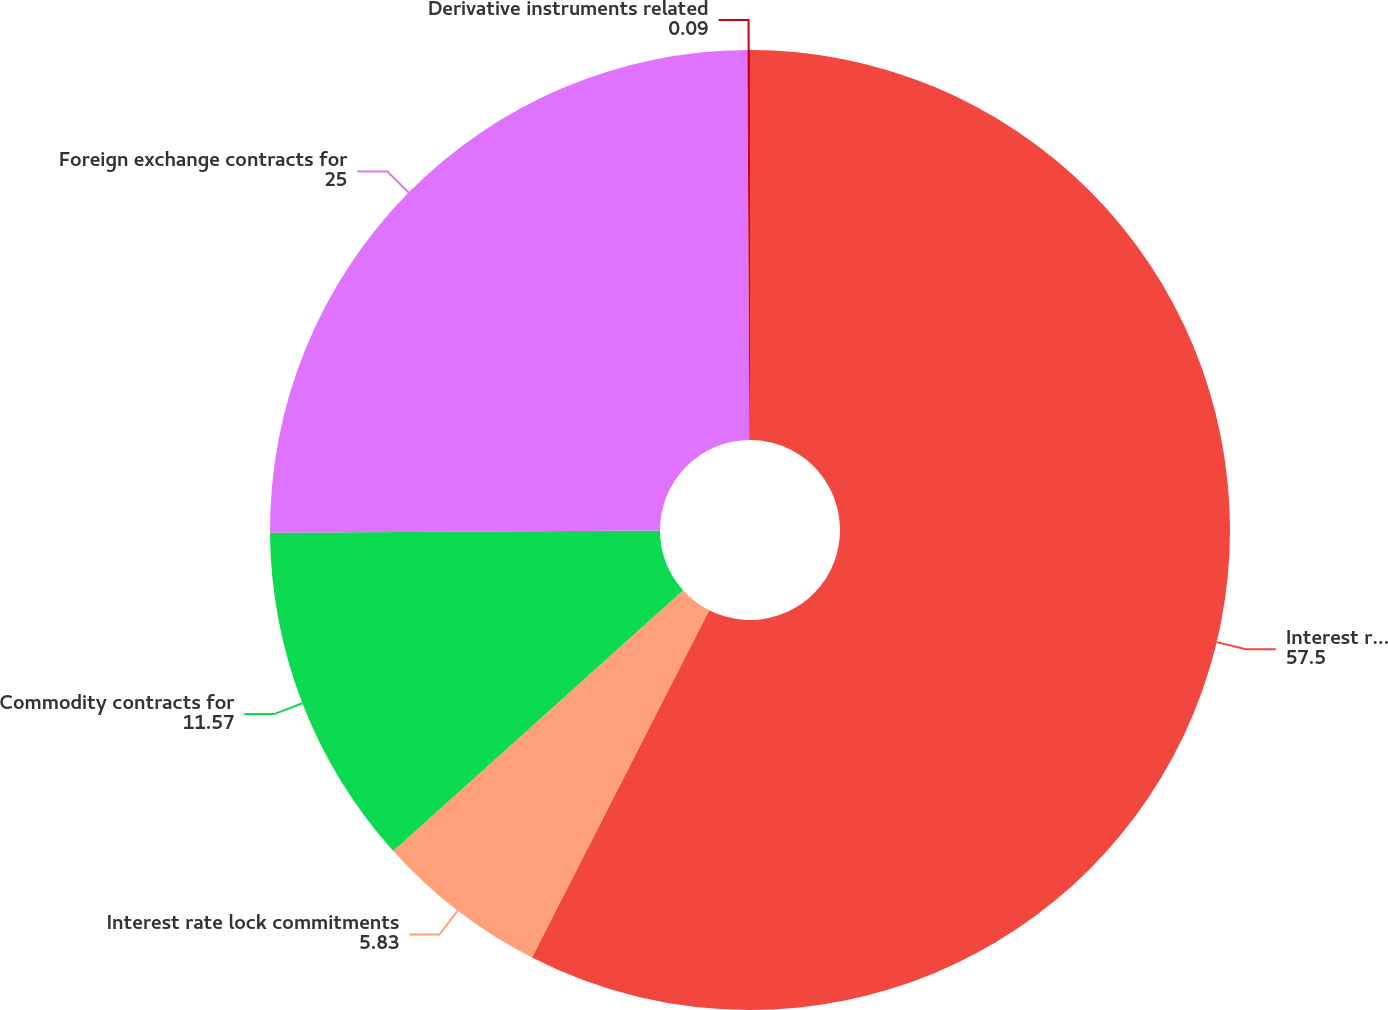<chart> <loc_0><loc_0><loc_500><loc_500><pie_chart><fcel>Interest rate contracts for<fcel>Interest rate lock commitments<fcel>Commodity contracts for<fcel>Foreign exchange contracts for<fcel>Derivative instruments related<nl><fcel>57.5%<fcel>5.83%<fcel>11.57%<fcel>25.0%<fcel>0.09%<nl></chart> 